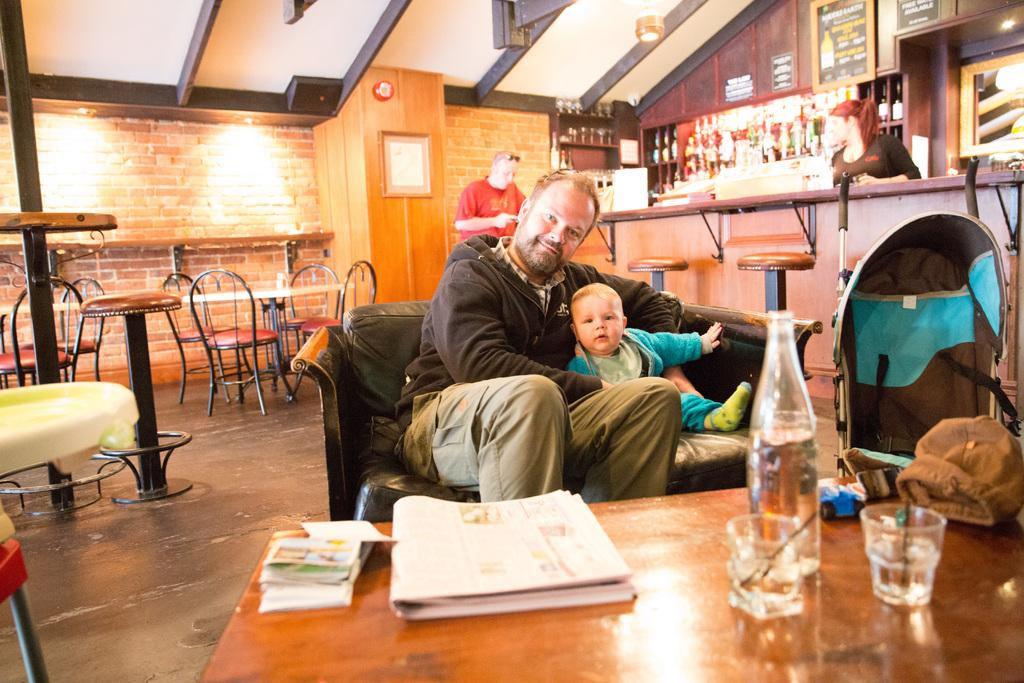How many people are present in the image? There are four people in the image. What type of furniture can be seen in the image? There are many chairs and at least one table in the image. What objects are on the table? There is a glass and a bottle on the table. Where are additional bottles located in the image? There are many bottles on a shelf. How does the plane join the people in the image? There is no plane present in the image, so it cannot join the people. 